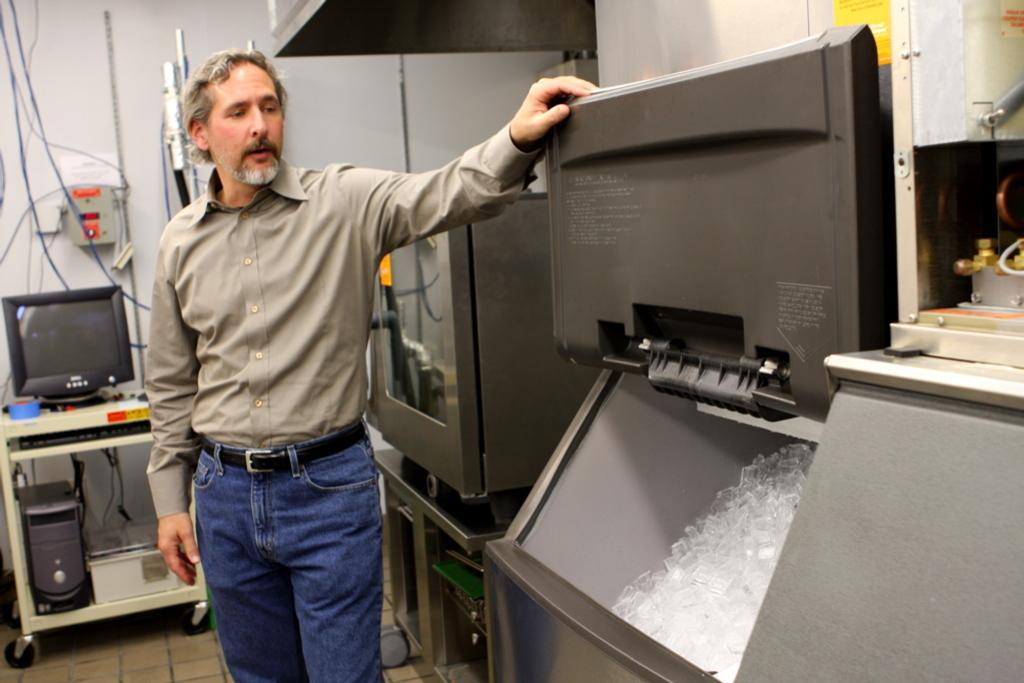What is the main subject in the image? There is a person in the image. What type of equipment can be seen in the image? There are monitors and a CPU in the image. What is the background of the image? There is a wall in the image. Can you describe any other objects present in the image? There are some unspecified objects in the image. How many snakes are slithering on the wall in the image? There are no snakes present in the image. What type of monkey can be seen interacting with the person in the image? There is no monkey present in the image. What is the topic of the argument between the person and the monkey in the image? There is no argument present in the image, as there is no monkey present. 